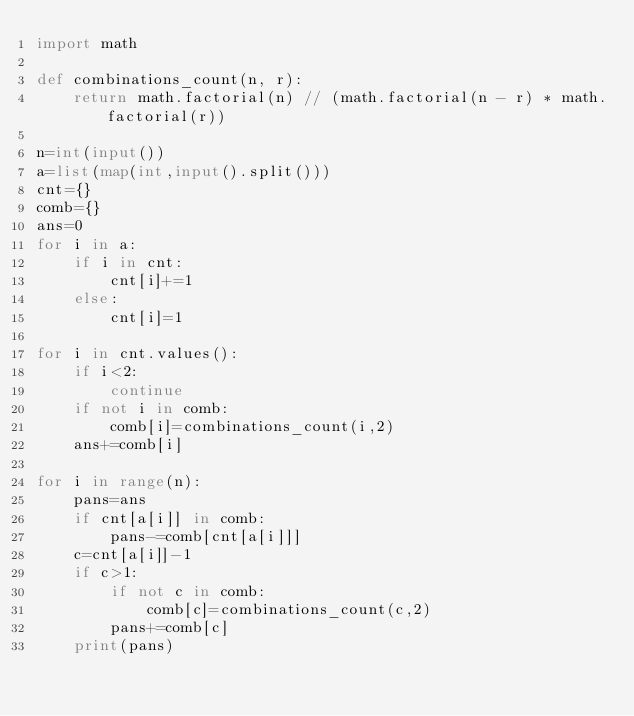<code> <loc_0><loc_0><loc_500><loc_500><_Python_>import math

def combinations_count(n, r):
    return math.factorial(n) // (math.factorial(n - r) * math.factorial(r))

n=int(input())
a=list(map(int,input().split()))
cnt={}
comb={}
ans=0
for i in a:
    if i in cnt:
        cnt[i]+=1
    else:
        cnt[i]=1
        
for i in cnt.values():
    if i<2:
        continue
    if not i in comb:
        comb[i]=combinations_count(i,2)
    ans+=comb[i]

for i in range(n):
    pans=ans
    if cnt[a[i]] in comb:
        pans-=comb[cnt[a[i]]]
    c=cnt[a[i]]-1
    if c>1:
        if not c in comb:
            comb[c]=combinations_count(c,2)
        pans+=comb[c]
    print(pans)
</code> 